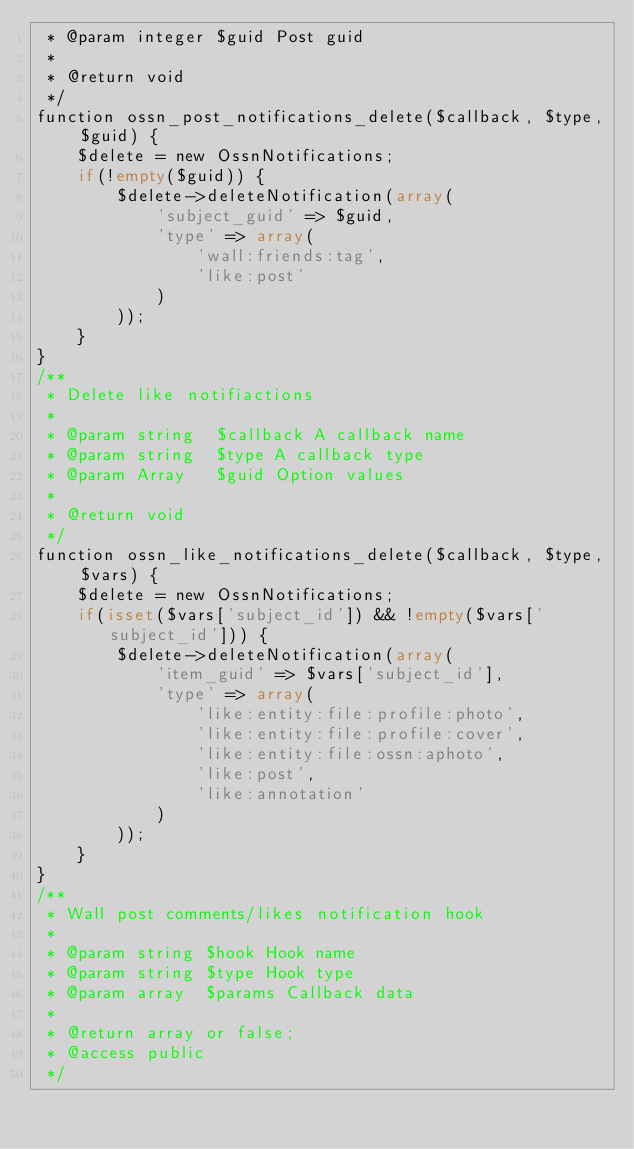<code> <loc_0><loc_0><loc_500><loc_500><_PHP_> * @param integer $guid Post guid
 *
 * @return void
 */
function ossn_post_notifications_delete($callback, $type, $guid) {
		$delete = new OssnNotifications;
		if(!empty($guid)) {
				$delete->deleteNotification(array(
						'subject_guid' => $guid,
						'type' => array(
								'wall:friends:tag',
								'like:post'
						)
				));
		}
}
/**
 * Delete like notifiactions
 *
 * @param string  $callback A callback name
 * @param string  $type A callback type
 * @param Array   $guid Option values
 *
 * @return void
 */
function ossn_like_notifications_delete($callback, $type, $vars) {
		$delete = new OssnNotifications;
		if(isset($vars['subject_id']) && !empty($vars['subject_id'])) {
				$delete->deleteNotification(array(
						'item_guid' => $vars['subject_id'],
						'type' => array(
								'like:entity:file:profile:photo',
								'like:entity:file:profile:cover',
								'like:entity:file:ossn:aphoto',
								'like:post',
								'like:annotation'
						)
				));
		}
}
/**
 * Wall post comments/likes notification hook
 *
 * @param string $hook Hook name
 * @param string $type Hook type
 * @param array  $params Callback data
 *
 * @return array or false;
 * @access public
 */</code> 